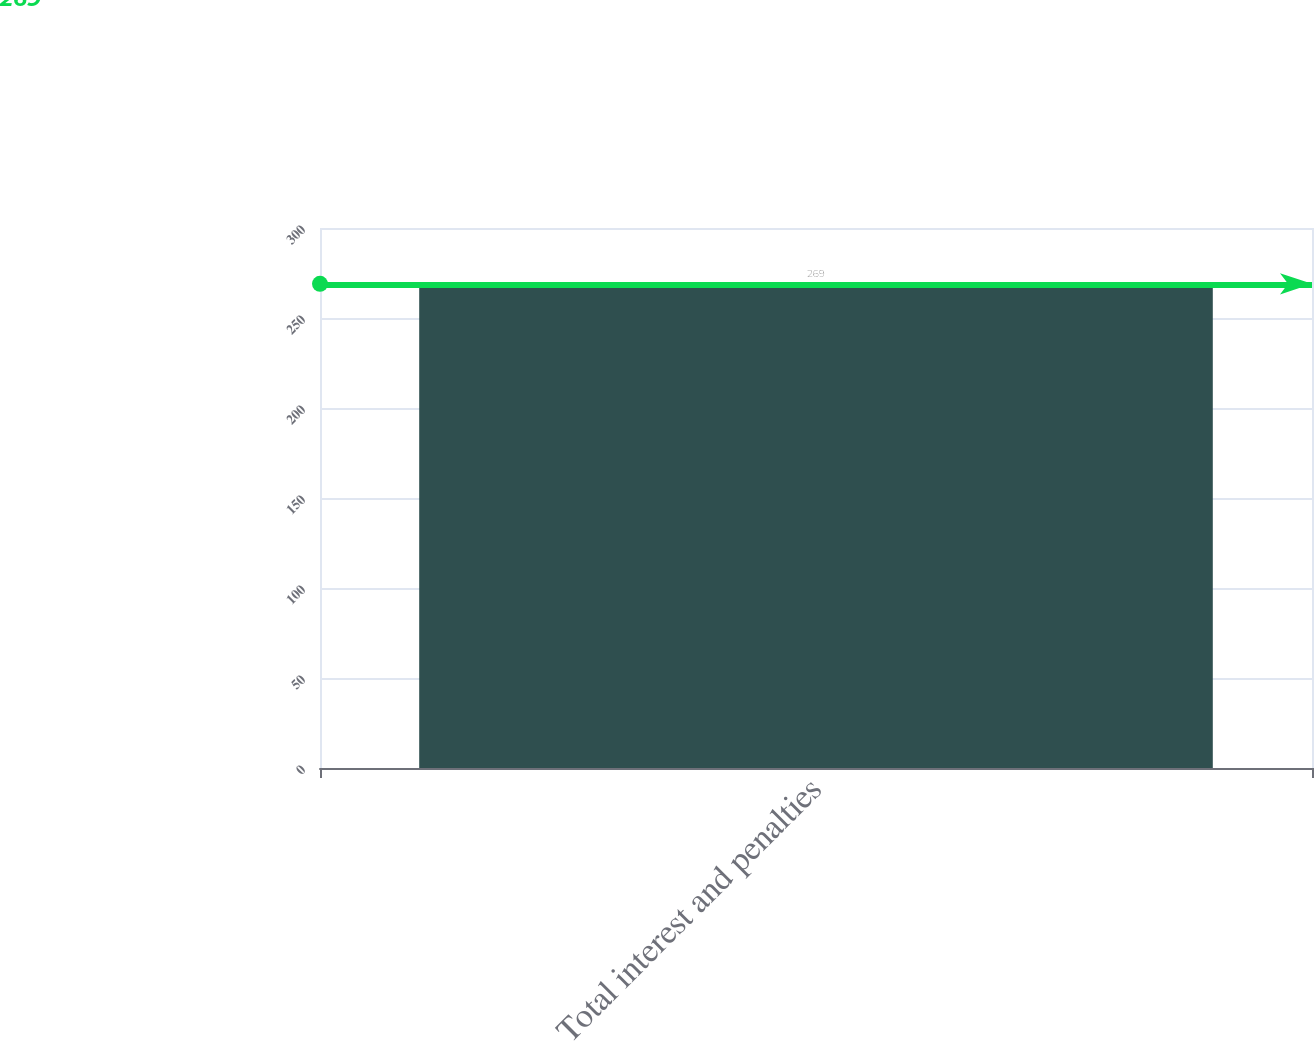Convert chart. <chart><loc_0><loc_0><loc_500><loc_500><bar_chart><fcel>Total interest and penalties<nl><fcel>269<nl></chart> 